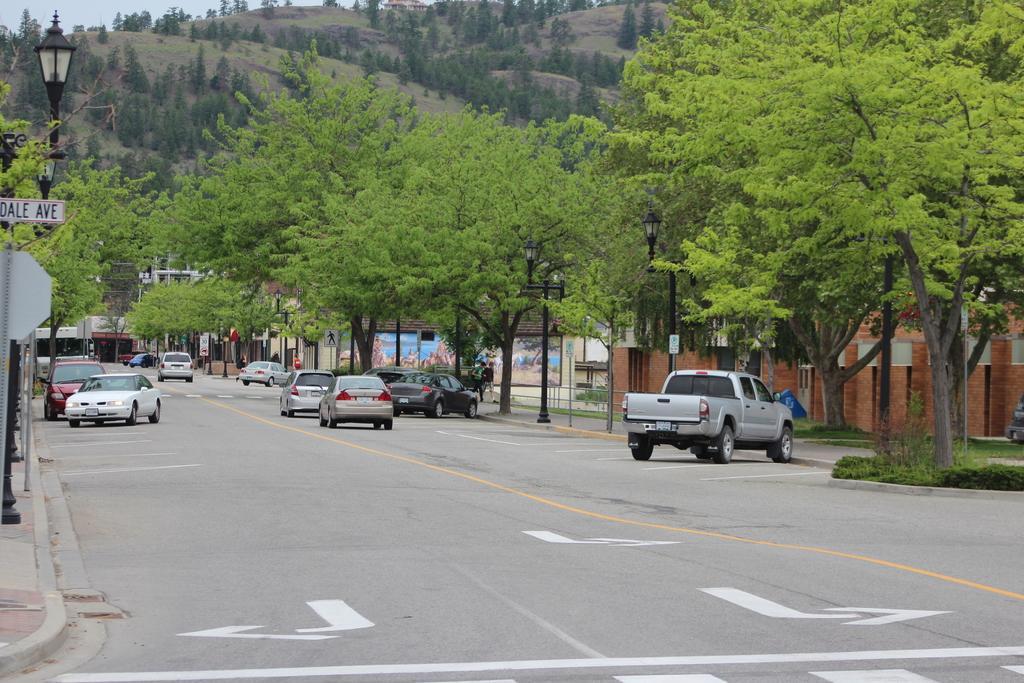Please provide a concise description of this image. As we can see in the image there are vehicles, grass, buildings, street lamps, sign poles, trees and hills. 